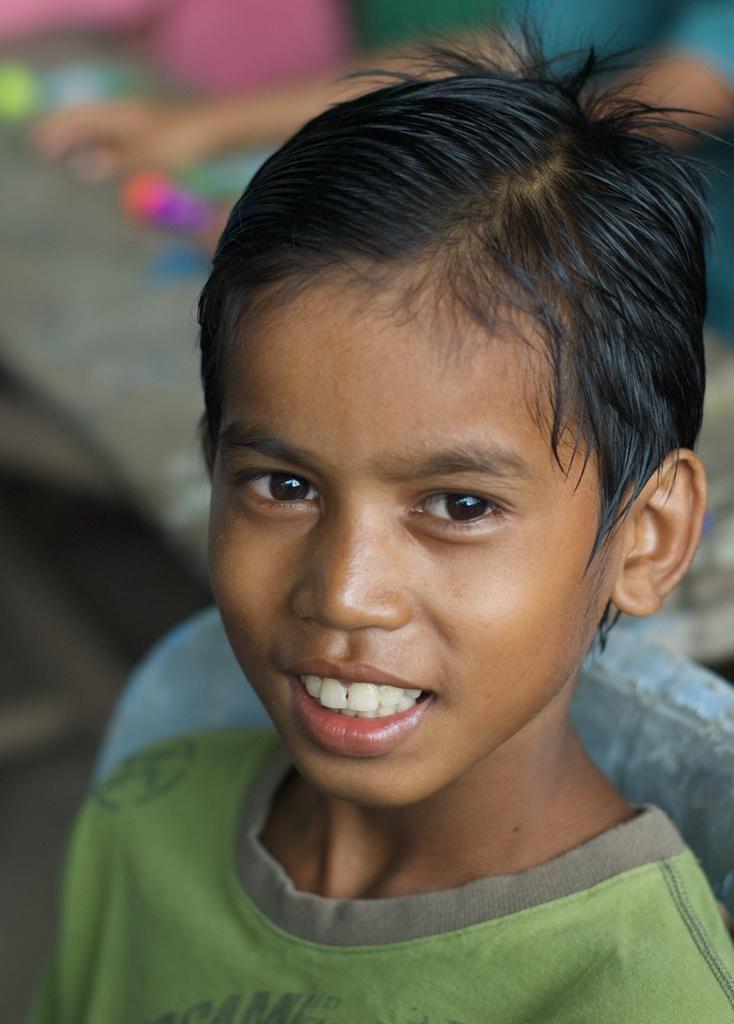Can you describe this image briefly? In this picture a boy is highlighted and he is holding a smile on his face. He is wearing a light green colour t shirt. On the background of the picture we are able to see one human and its very blur. 